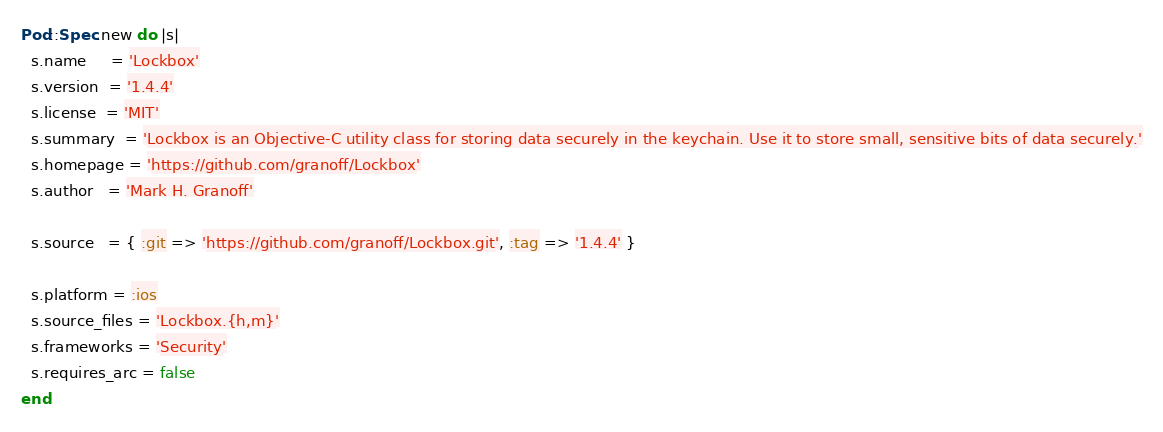Convert code to text. <code><loc_0><loc_0><loc_500><loc_500><_Ruby_>Pod::Spec.new do |s|
  s.name     = 'Lockbox'
  s.version  = '1.4.4'
  s.license  = 'MIT'
  s.summary  = 'Lockbox is an Objective-C utility class for storing data securely in the keychain. Use it to store small, sensitive bits of data securely.'
  s.homepage = 'https://github.com/granoff/Lockbox'
  s.author   = 'Mark H. Granoff'

  s.source   = { :git => 'https://github.com/granoff/Lockbox.git', :tag => '1.4.4' }

  s.platform = :ios
  s.source_files = 'Lockbox.{h,m}'
  s.frameworks = 'Security'
  s.requires_arc = false
end
</code> 